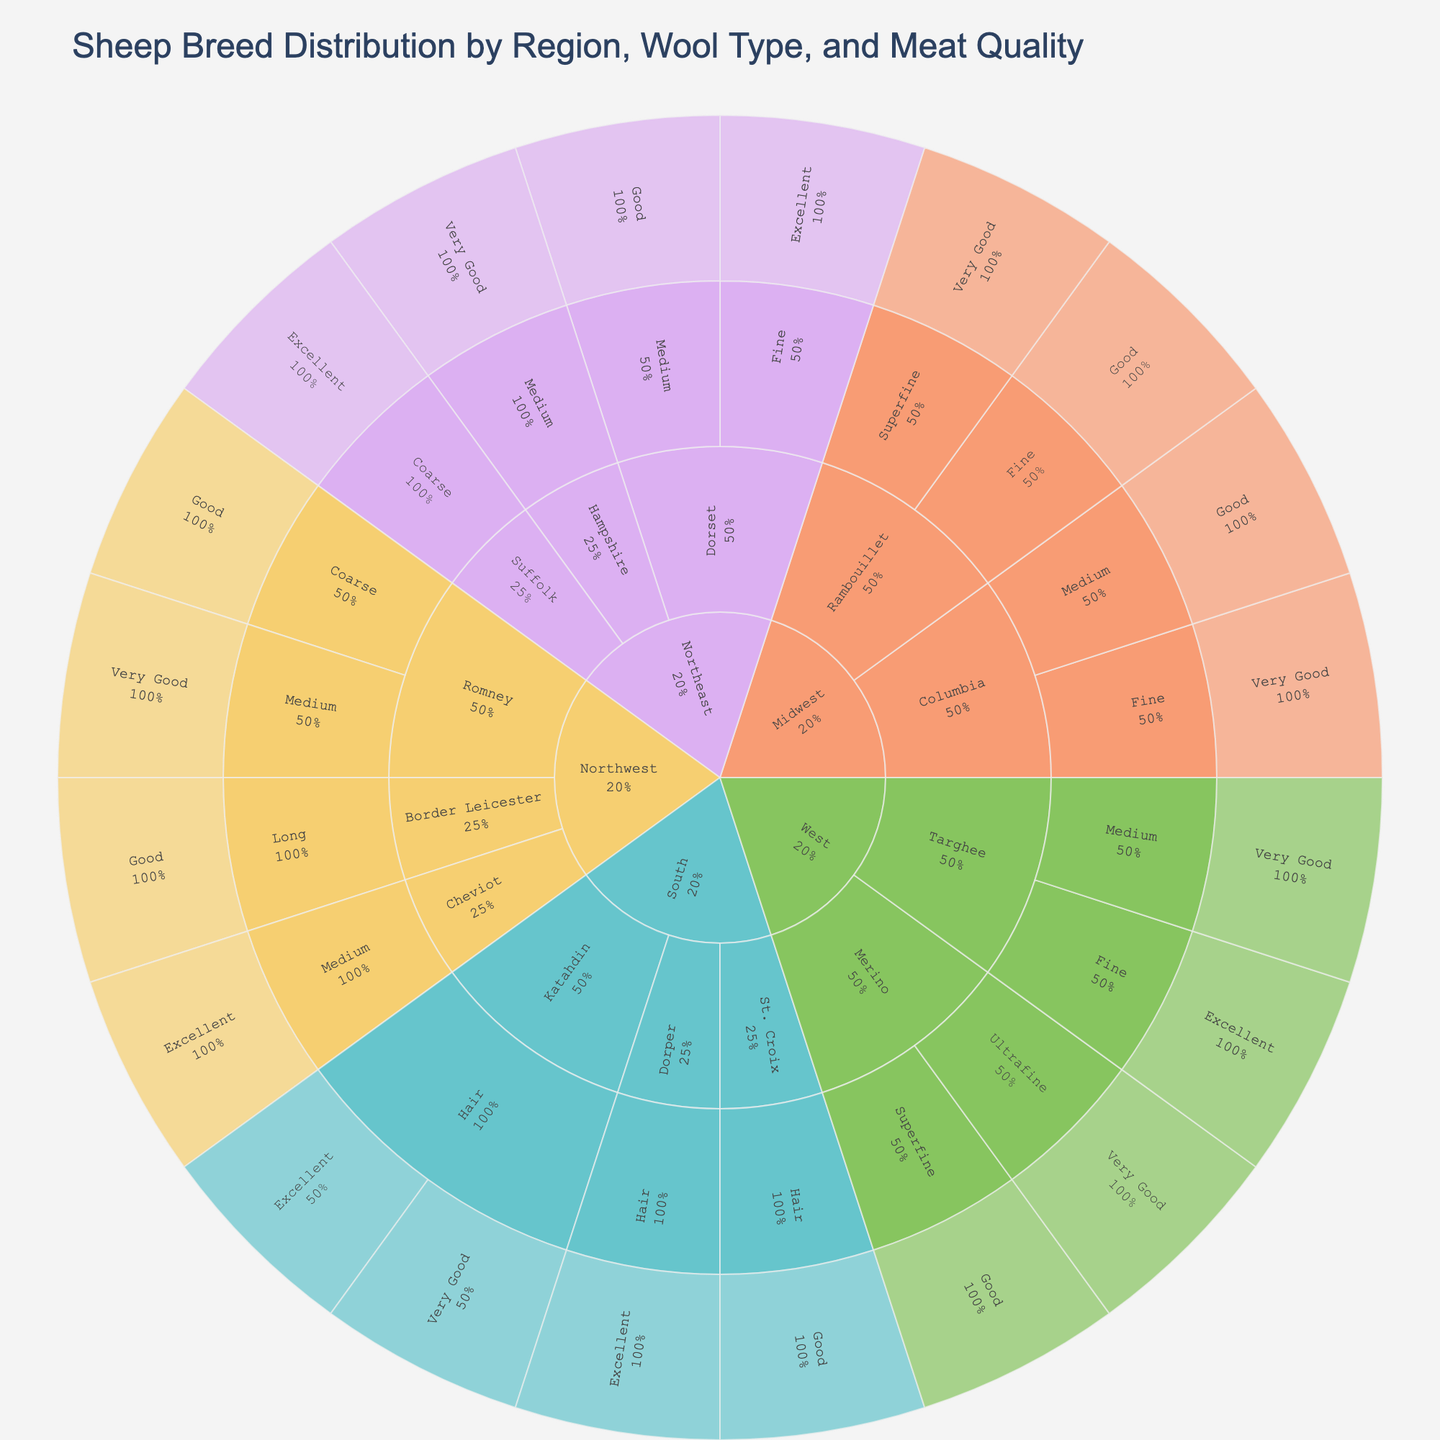what is the title of the figure? The title is found at the top of the plot. It is usually a brief explanation of what the plot represents.
Answer: Sheep Breed Distribution by Region, Wool Type, and Meat Quality Which region has the most diverse wool types? To determine this, look at the size of sections under each region and how many different wool types are represented. The "Northeast" region shows Medium, Fine, and Coarse wool types.
Answer: Northeast In which region is the "Excellent" meat quality most common? This can be found by looking at the sub-segments labeled "Excellent" within each region's segment. The "Excellent" meat quality sub-segments appear larger in the "Northeast" region.
Answer: Northeast What proportion of the total sheep breeds in the South have "Excellent" meat quality? First, identify all sheep breeds in the South region. Then, find the sub-segment labeled "Excellent" and compare its size to other quality levels. Both Katahdin and Dorper breeds have "Excellent" meat quality, making it 50%.
Answer: 50% Compare the wool types of Merino breed in the West. Which wool type has better meat quality? Look under the "West" region, then the "Merino" breed, and compare the meat quality within "Superfine" and "Ultrafine" wool types. "Ultrafine" has better meat quality as it has a "Very Good" rating.
Answer: Ultrafine How many breeds in the Midwest region have "Fine" wool types? Look under the "Midwest" region and count the breeds that have a "Fine" wool type. Both Columbia and Rambouillet breeds have "Fine" wool types.
Answer: 2 Which region has the least variation in meat quality? Compare the number of different meat quality labels within each region’s segment. The "Northwest" region has a representation of "Good", "Very Good", and "Excellent", implying more even variation across three categories.
Answer: Northwest Which wool type appears exclusively in one region? Identify the wool types and check if any are listed under only one regional segment. The "Hair" wool type is only in the "South" region.
Answer: Hair 